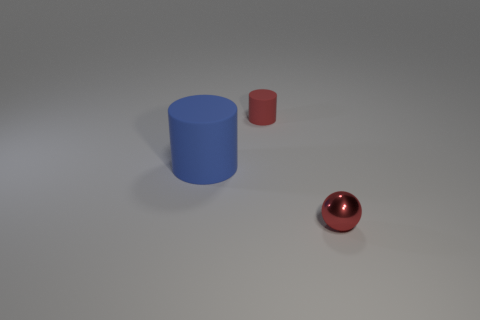What is the shape of the small matte object that is the same color as the shiny thing?
Your answer should be very brief. Cylinder. What number of other tiny rubber things have the same shape as the blue matte object?
Ensure brevity in your answer.  1. What material is the tiny red object in front of the rubber thing that is on the left side of the small cylinder?
Keep it short and to the point. Metal. Are there an equal number of matte cylinders and shiny things?
Provide a succinct answer. No. How big is the rubber cylinder that is on the left side of the red matte thing?
Offer a very short reply. Large. How many brown objects are either rubber things or tiny metallic objects?
Provide a succinct answer. 0. Is there anything else that is the same material as the red sphere?
Your answer should be very brief. No. What material is the small red thing that is the same shape as the big blue rubber thing?
Your response must be concise. Rubber. Are there an equal number of small metal things on the left side of the tiny metallic thing and cylinders?
Your answer should be compact. No. How big is the object that is both on the left side of the shiny object and in front of the small red cylinder?
Keep it short and to the point. Large. 